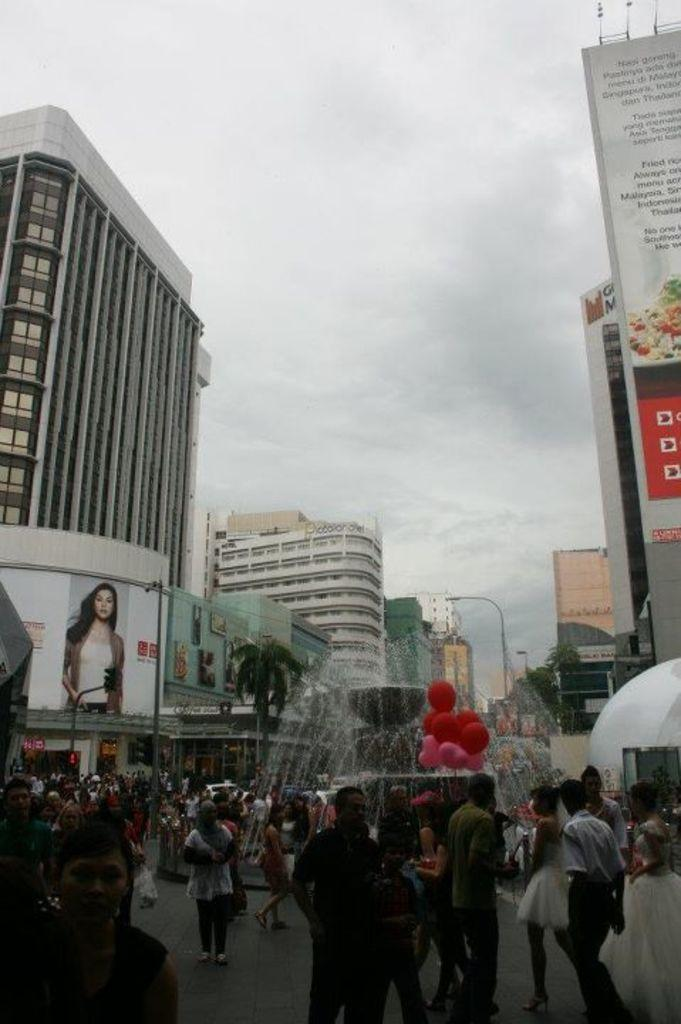What are the people in the image doing? The people in the image are walking on the road. What type of natural elements can be seen in the image? There are trees in the image. What type of man-made structures are present in the image? There are buildings in the image. What additional objects can be seen in the image? There are balloons, a fountain, a banner, a traffic light, and a pole in the image. What part of the natural environment is visible in the image? The sky is visible in the image. Can you see a family playing in the playground in the image? There is no playground present in the image, so it is not possible to see a family playing there. 